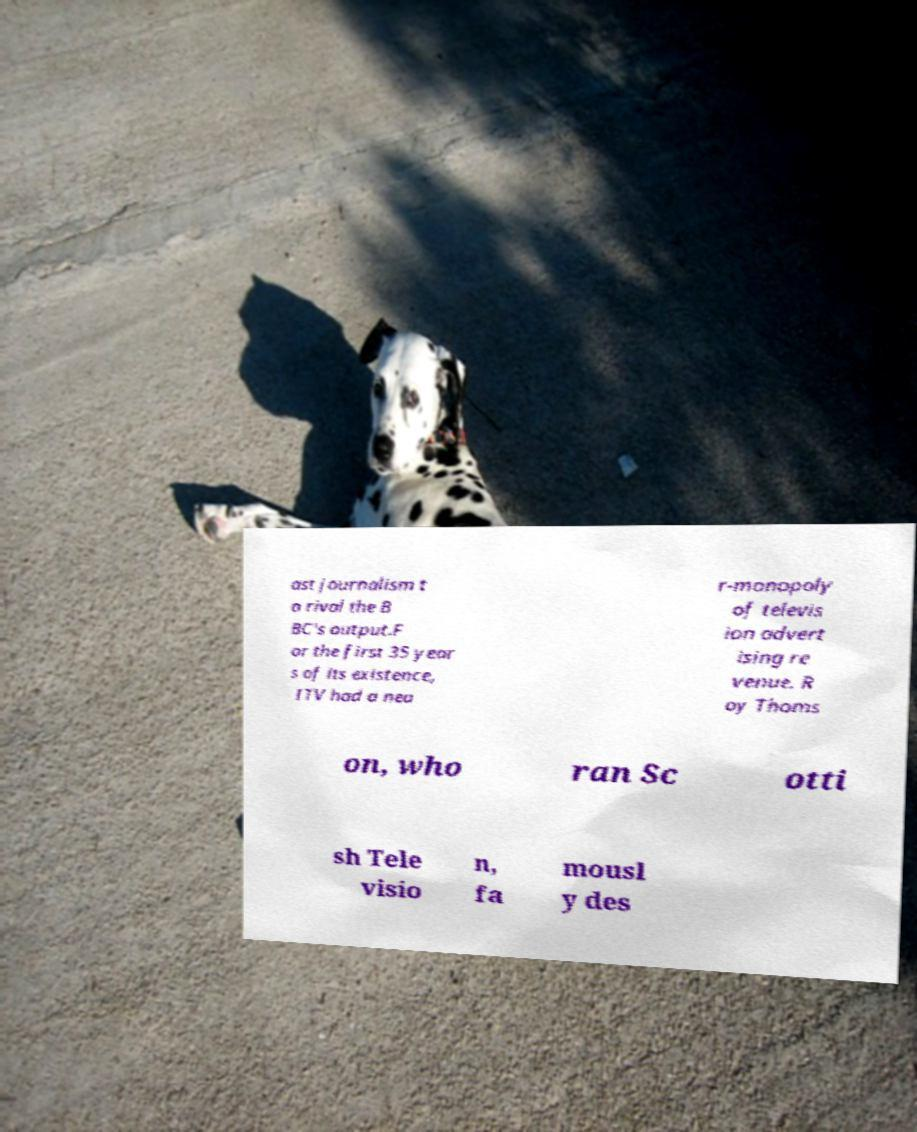Could you assist in decoding the text presented in this image and type it out clearly? ast journalism t o rival the B BC's output.F or the first 35 year s of its existence, ITV had a nea r-monopoly of televis ion advert ising re venue. R oy Thoms on, who ran Sc otti sh Tele visio n, fa mousl y des 